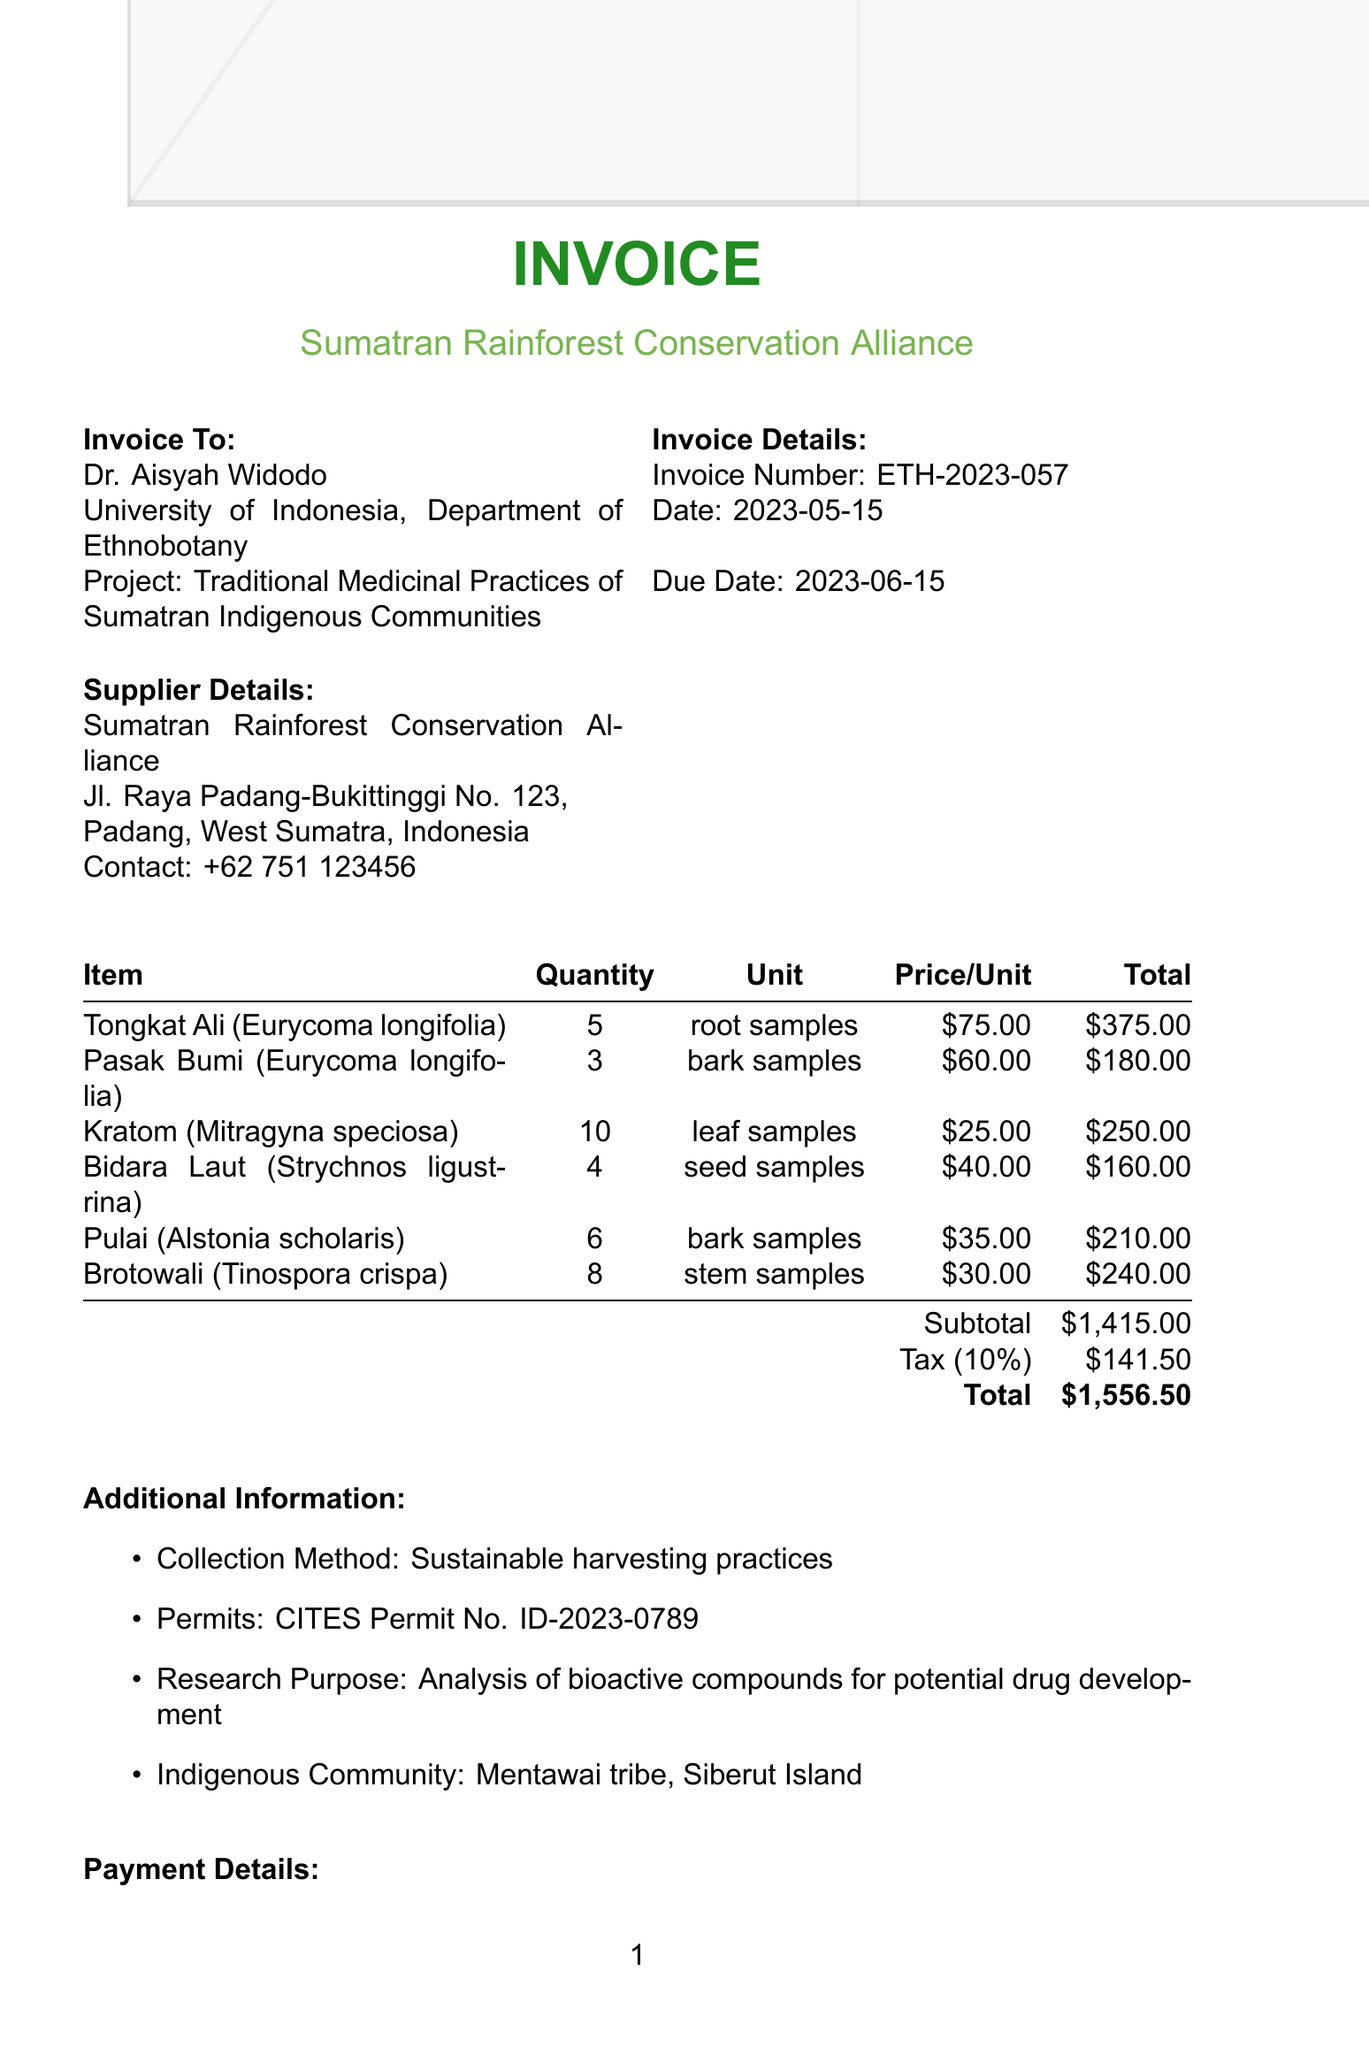What is the invoice number? The invoice number is specifically stated under "Invoice Details" in the document.
Answer: ETH-2023-057 Who is the researcher? The document lists the researcher’s name who is receiving the invoice.
Answer: Dr. Aisyah Widodo What is the payment method? The payment method is detailed in the "Payment Details" section of the document.
Answer: Wire transfer How many stem samples of Brotowali are included? The quantity of Brotowali is mentioned directly in the item list of the invoice.
Answer: 8 What is the total amount due? The total amount is summarized in the "Payment Details" section as the final calculated figure.
Answer: $1,556.50 What is the purpose of the research? The research purpose is stated in the "Additional Information" section of the document.
Answer: Analysis of bioactive compounds for potential drug development What date is the invoice due? The due date is provided in the "Invoice Details" section of the document.
Answer: 2023-06-15 Which indigenous community is mentioned? The specific indigenous community is listed under the "Additional Information" section of the document.
Answer: Mentawai tribe, Siberut Island What is the subtotal amount before tax? The subtotal is detailed in the "Payment Details" section prior to the tax amount.
Answer: $1,415.00 